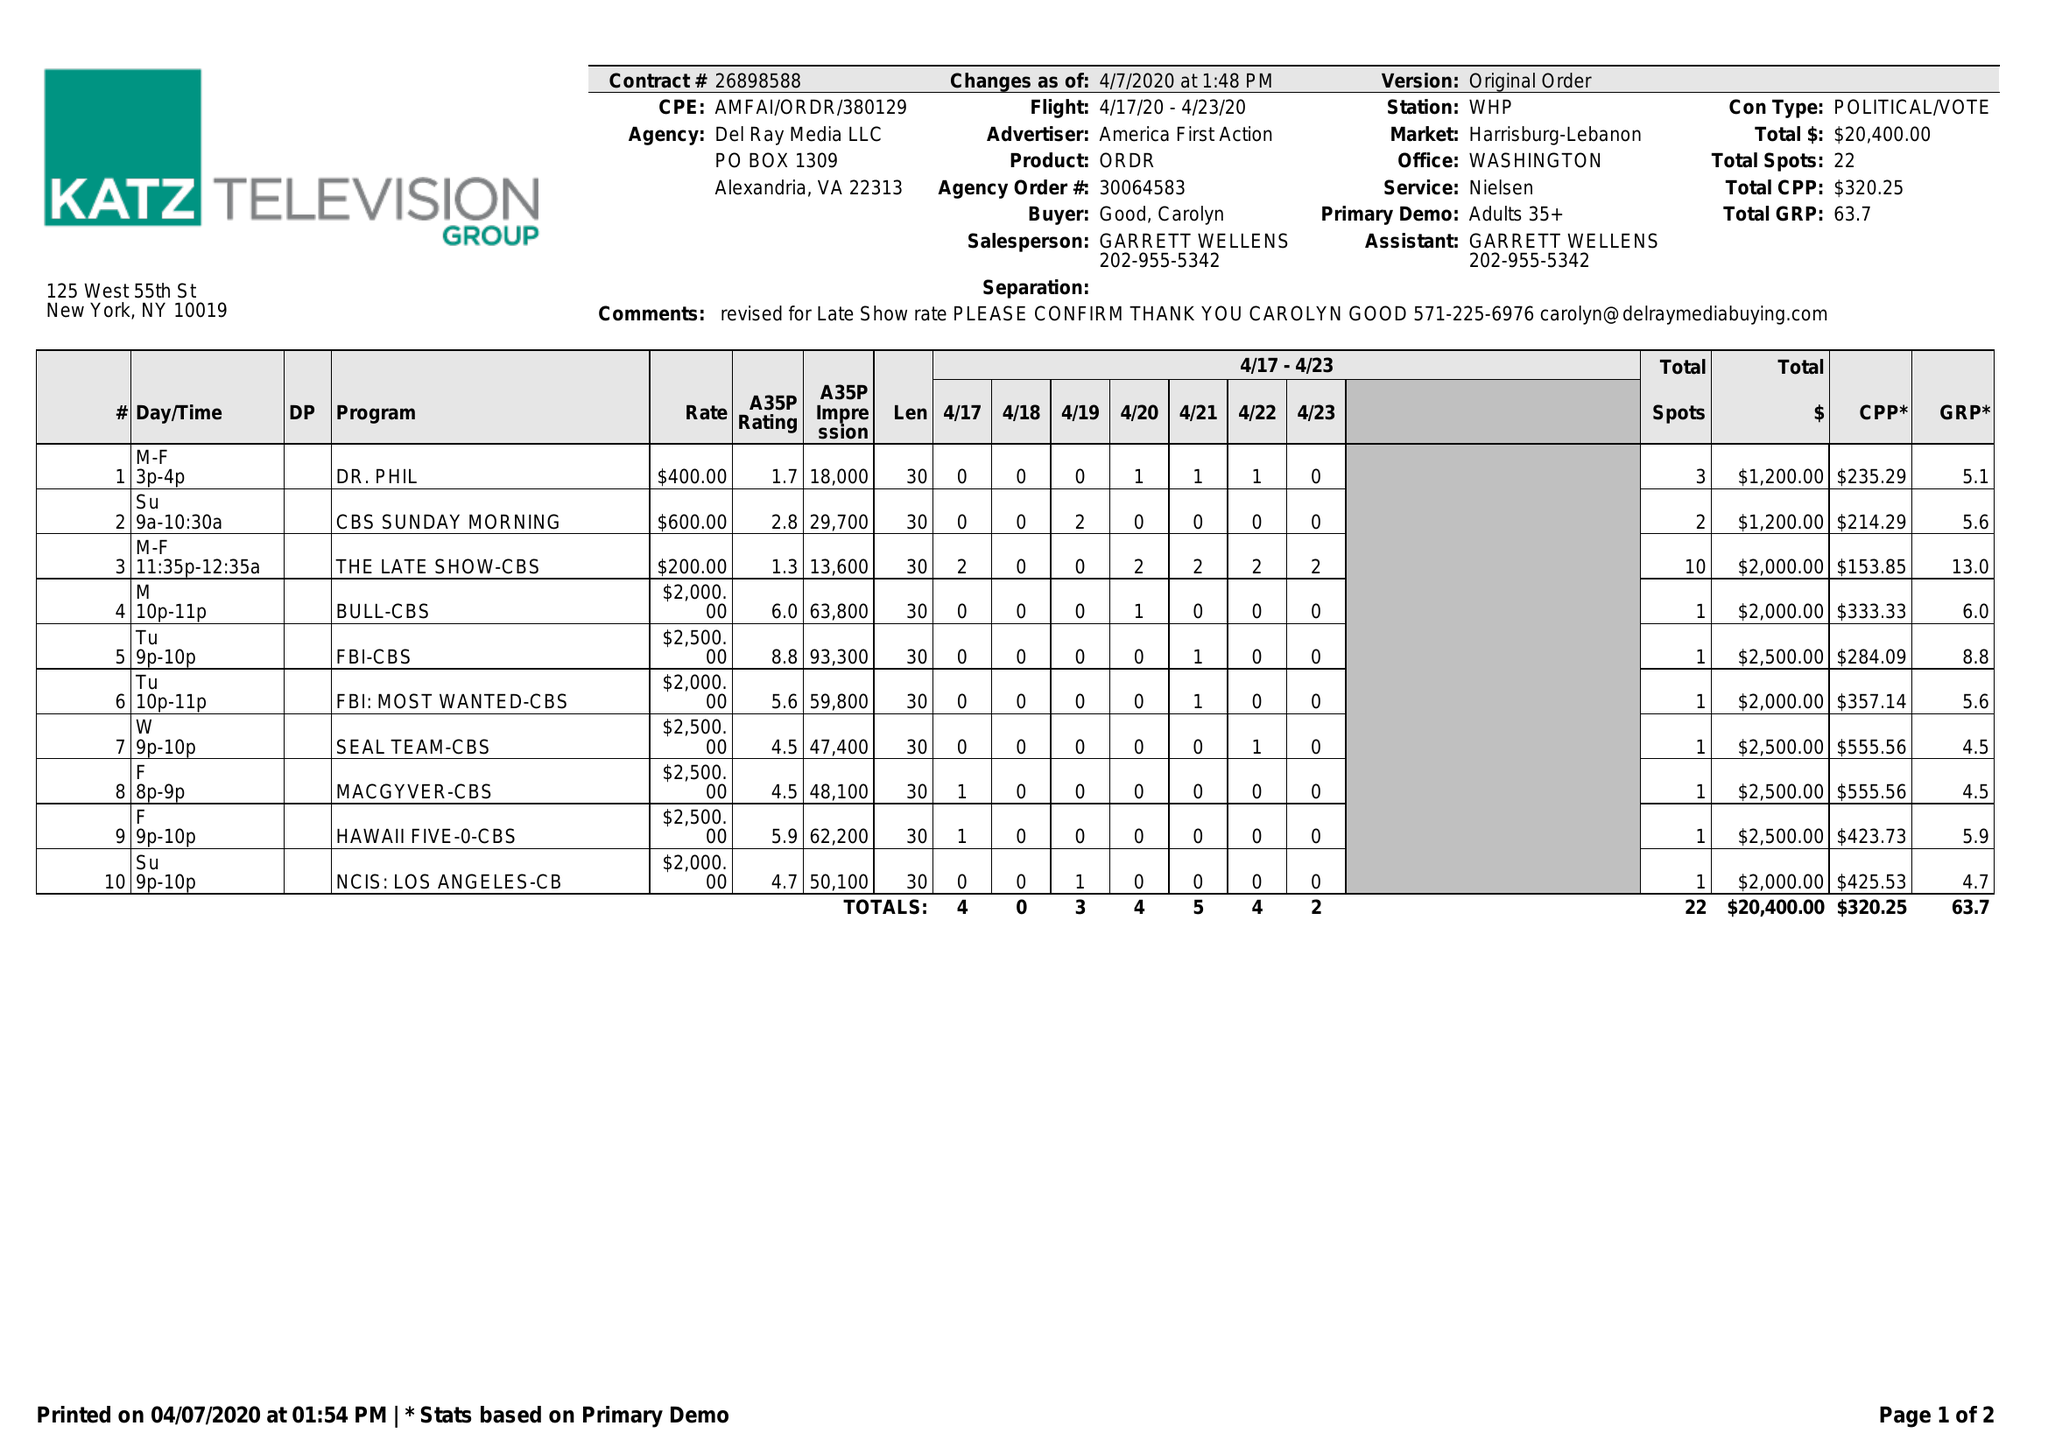What is the value for the gross_amount?
Answer the question using a single word or phrase. 20400.00 